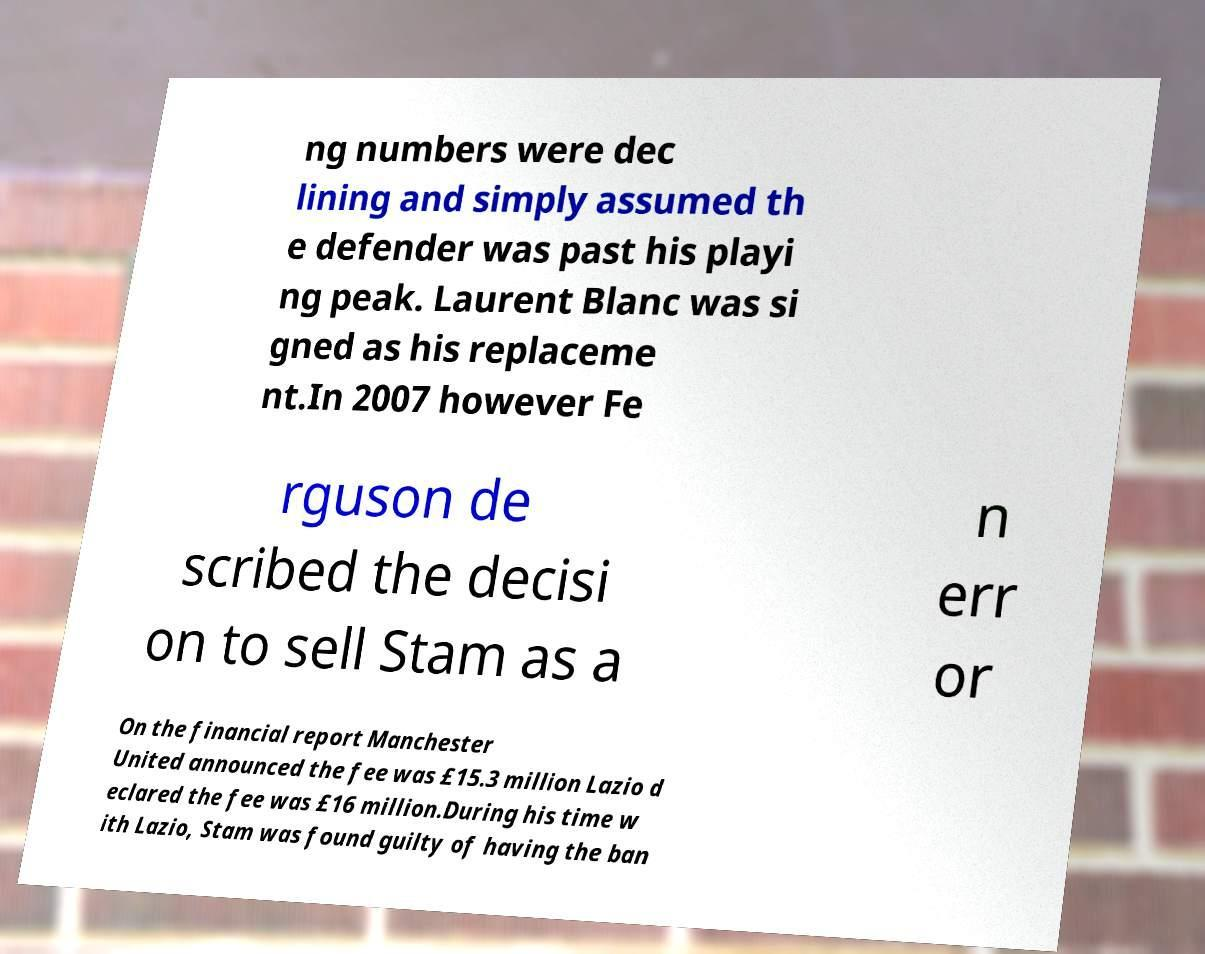Could you assist in decoding the text presented in this image and type it out clearly? ng numbers were dec lining and simply assumed th e defender was past his playi ng peak. Laurent Blanc was si gned as his replaceme nt.In 2007 however Fe rguson de scribed the decisi on to sell Stam as a n err or On the financial report Manchester United announced the fee was £15.3 million Lazio d eclared the fee was £16 million.During his time w ith Lazio, Stam was found guilty of having the ban 